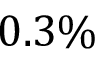<formula> <loc_0><loc_0><loc_500><loc_500>0 . 3 \%</formula> 